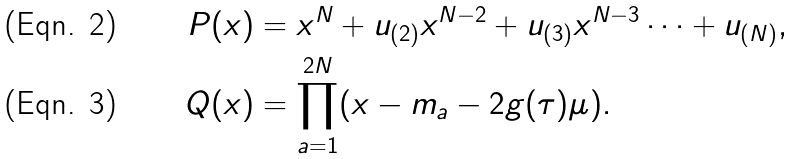<formula> <loc_0><loc_0><loc_500><loc_500>P ( x ) & = x ^ { N } + u _ { ( 2 ) } x ^ { N - 2 } + u _ { ( 3 ) } x ^ { N - 3 } \cdots + u _ { ( N ) } , \\ Q ( x ) & = \prod _ { a = 1 } ^ { 2 N } ( x - m _ { a } - 2 g ( \tau ) \mu ) .</formula> 